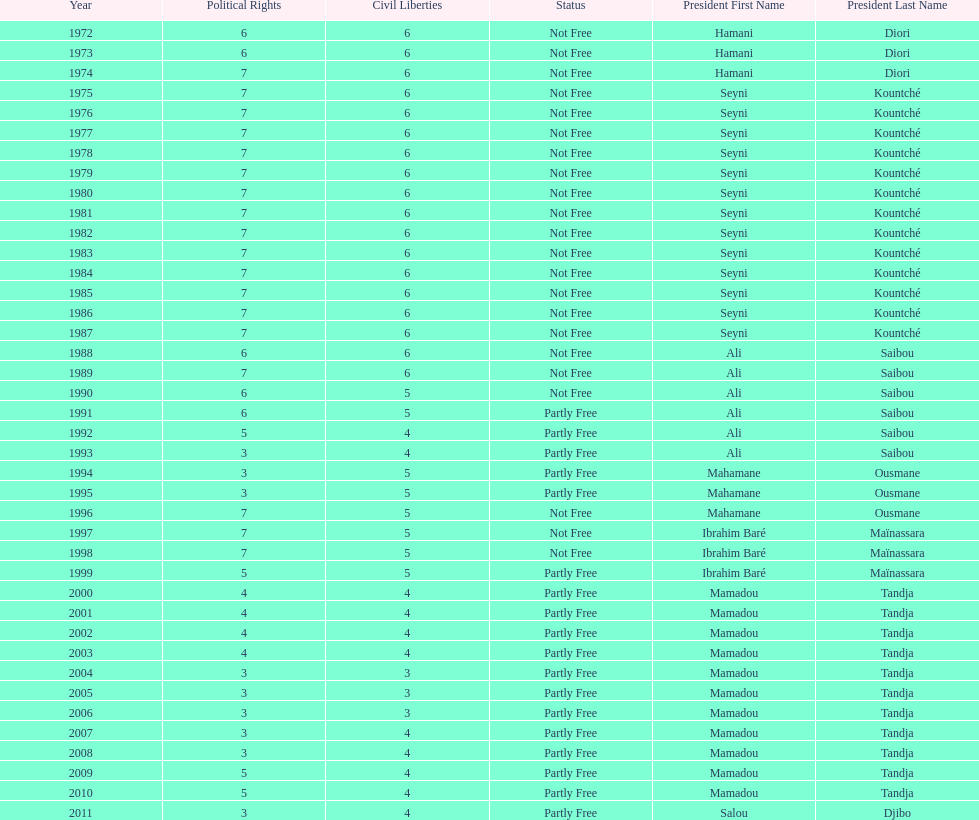Who ruled longer, ali saibou or mamadou tandja? Mamadou Tandja. 